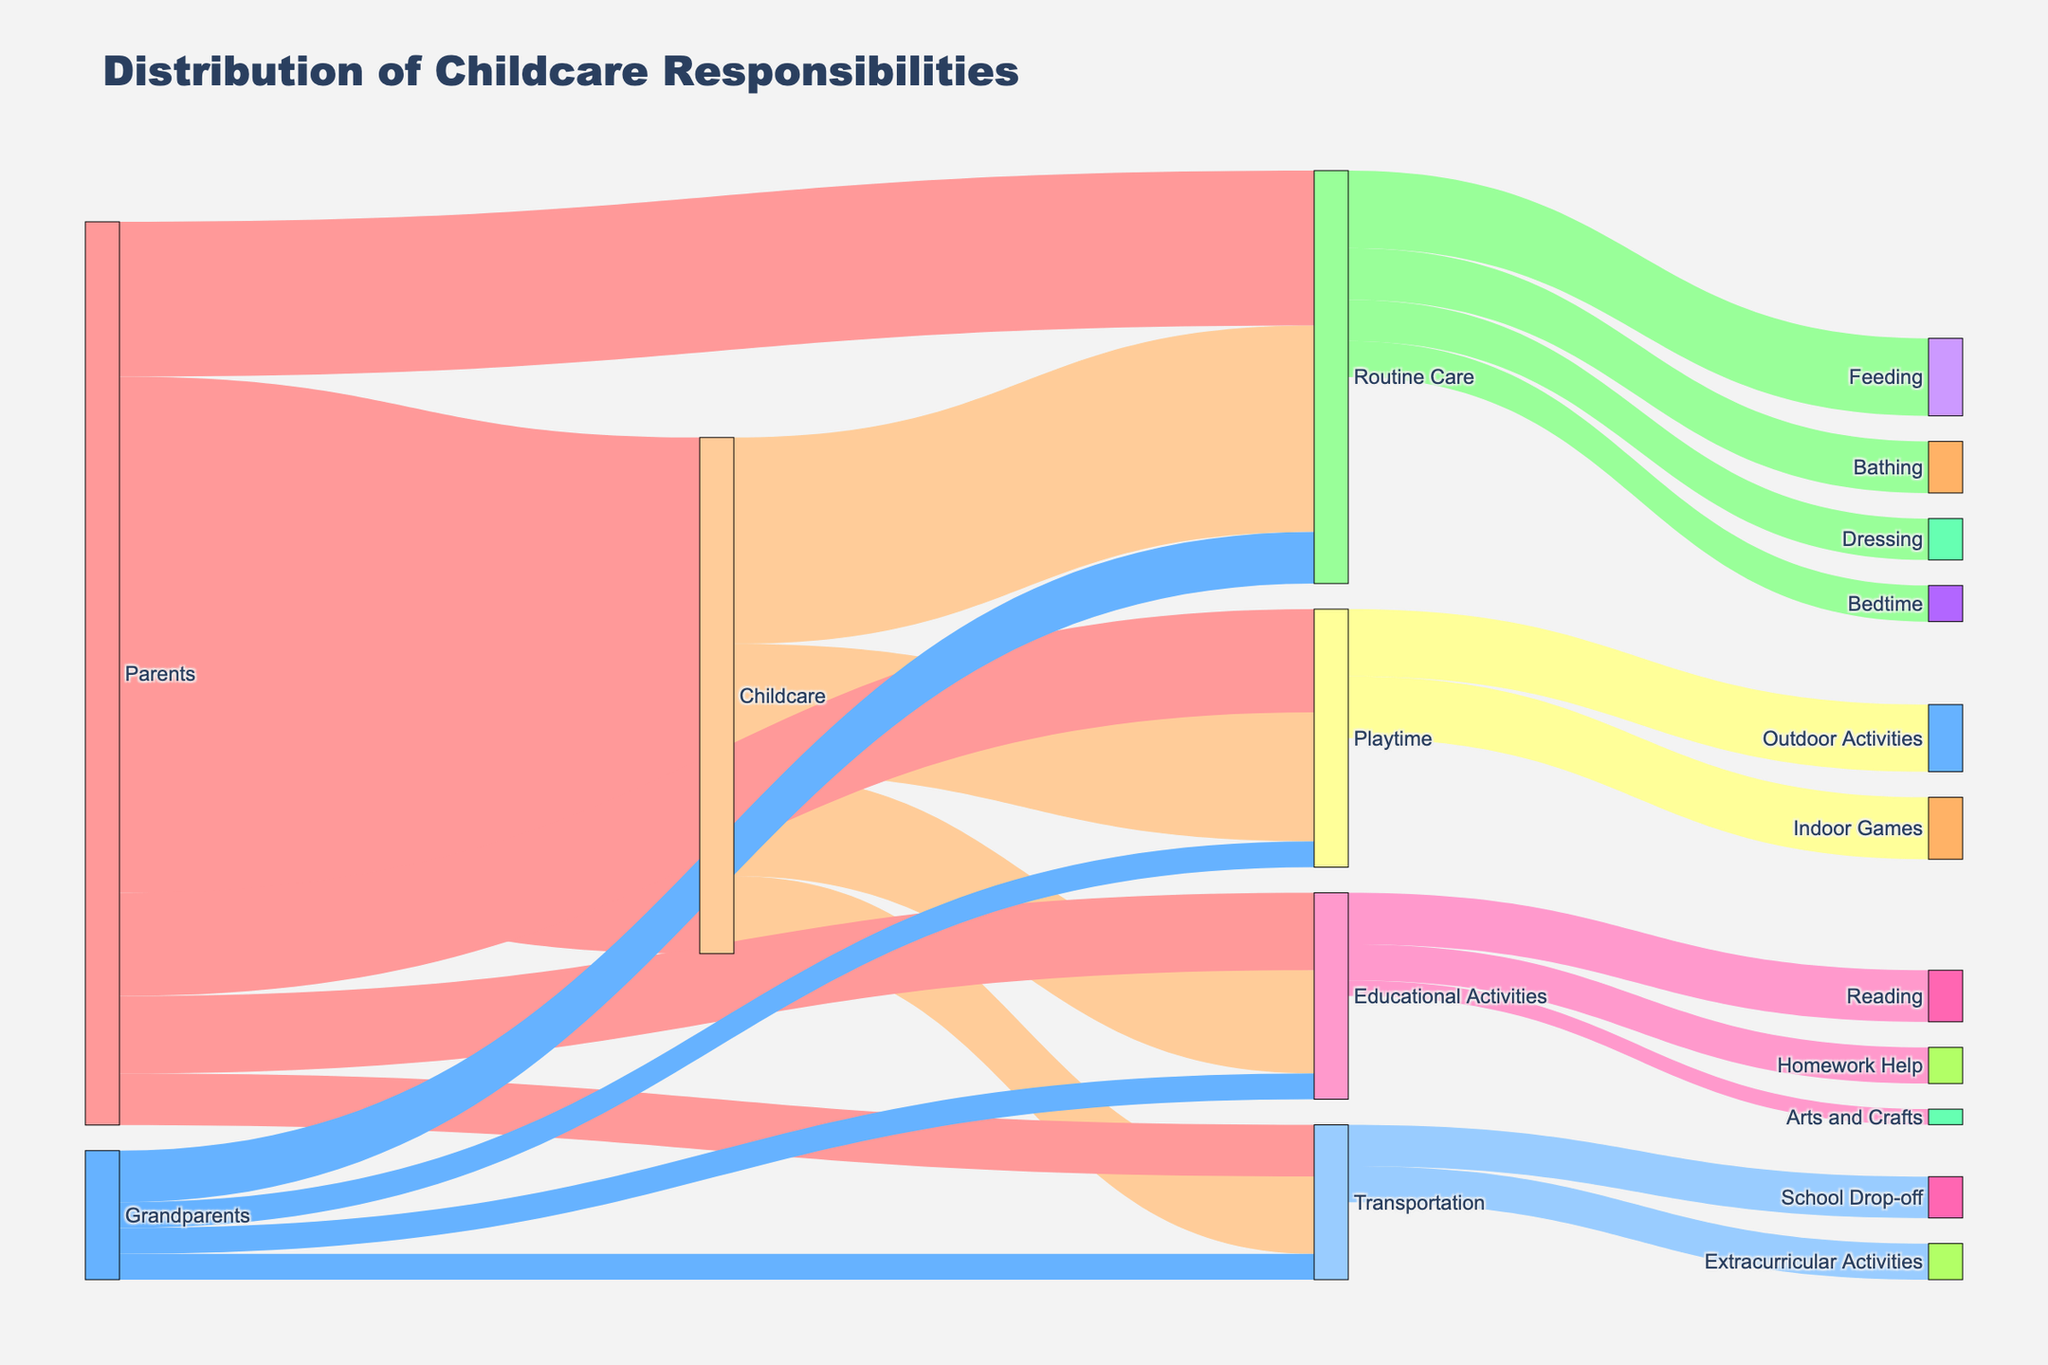Who is responsible for the majority of childcare? By looking at the Sankey diagram, the "Parents" contribute the most to "Childcare" with a value of 100. In comparison, there is no direct visible contribution like this for grandparents or other groups.
Answer: Parents How many total units are spent on Educational Activities? Summing the visual segments flowing to "Educational Activities" (20 from Childcare, 15 from Parents, and 5 from Grandparents), the total is 20 + 15 + 5 = 40.
Answer: 40 Who contributes more to Routine Care, parents or grandparents? The labels show that "Parents" contribute 30 units to "Routine Care", while "Grandparents" contribute 10 units. By comparing the values, it's clear that parents contribute more.
Answer: Parents Which type of care has the highest contribution from grandparents? Breaking down the sectors of grandparents' contributions: Routine Care (10), Educational Activities (5), Playtime (5), and Transportation (5), we see Routine Care has the highest contribution.
Answer: Routine Care How is the value of 15 for Transportation distributed in terms of specific activities? From Transportation, the figure shows connections to "School Drop-off" (8) and "Extracurricular Activities" (7). Together, these add up to the full value of 15.
Answer: School Drop-off: 8, Extracurricular Activities: 7 